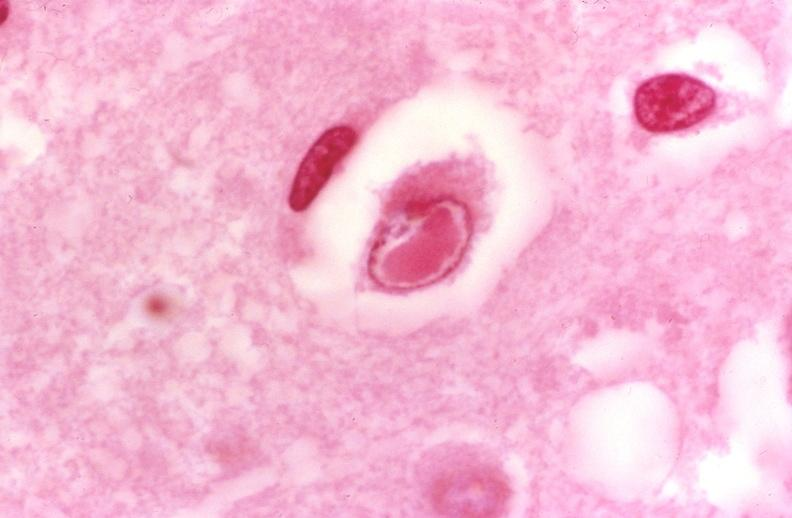does this image show brain, herpes inclusion bodies?
Answer the question using a single word or phrase. Yes 